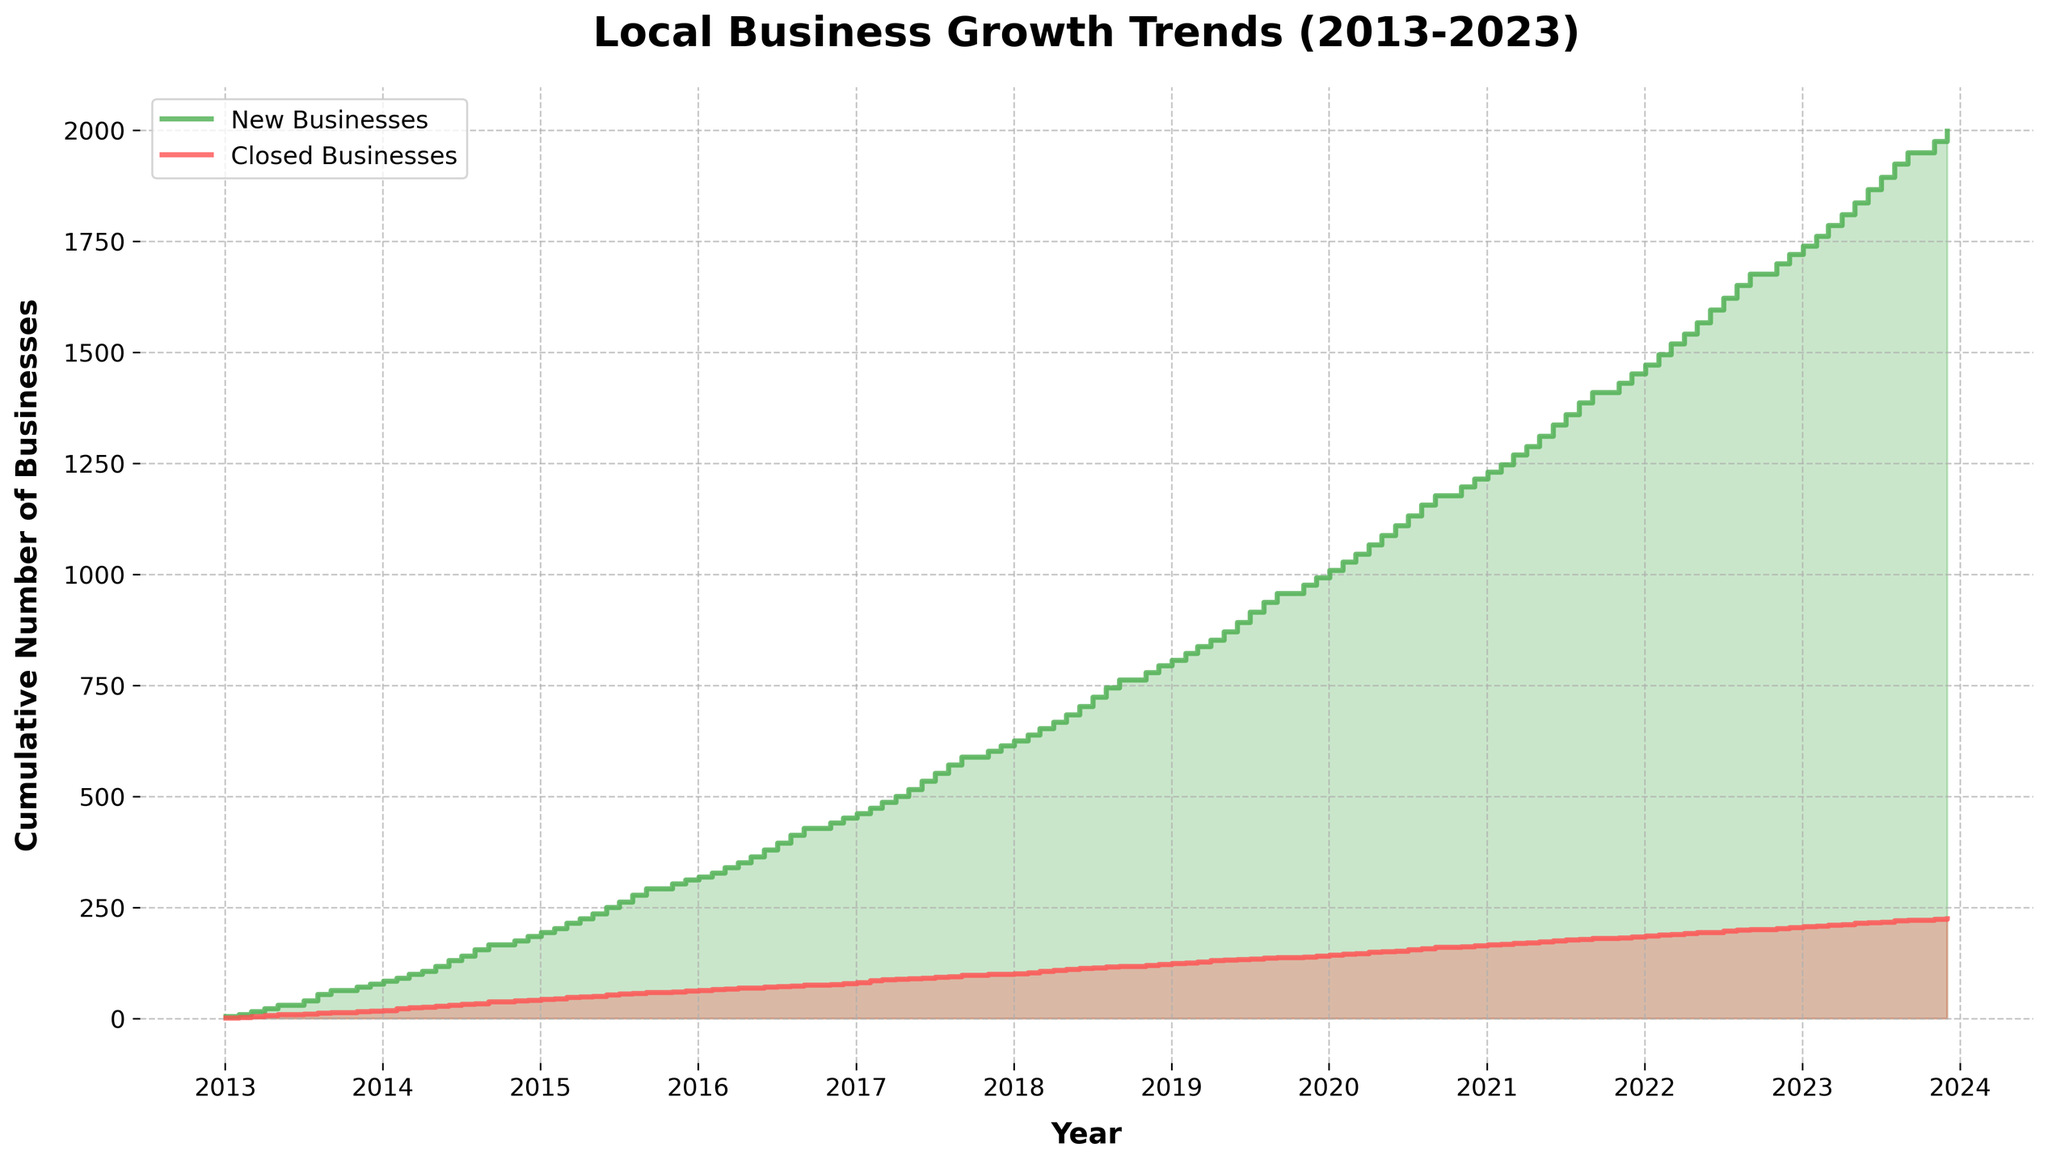What are the two lines representing in the figure? The figure has a title indicating it shows Local Business Growth Trends Over the Last Decade. The legend displays two labels: "New Businesses" and "Closed Businesses," which correlate with the two lines representing cumulative counts of new and closed businesses over time.
Answer: New businesses and closed businesses How many new businesses were opened by the end of 2023? By following the green line to its end point on the right-hand side of the plot, it reaches a cumulative count at the end of 2023. Estimating from the axis, it looks like approximately 472 new businesses were opened by the end of 2023.
Answer: 472 What is the trend observed for closed businesses between 2013 and 2023? Observing the red line throughout the plot, it continually increases from the left to the right, indicating that the number of closed businesses cumulatively increased over this period.
Answer: Increasing In which year was the highest number of new businesses opened in a single month? The plot allows comparing vertical leaps between steps for new businesses. The largest leap is around mid-2023, corresponding to July, when 30 new businesses were opened.
Answer: 2023 Which year had the smallest number of closed businesses? Observing the red line, the smallest steps occur in the year 2013, indicating fewer businesses closed in that year compared to others.
Answer: 2013 How many total businesses were closed by the end of 2016? Follow the red line to its position at the end of 2016. It reaches approximately the level corresponding to 47 from the adopted scale.
Answer: 47 What can you infer about the growth trend of local businesses by comparing the two lines in 2020? In 2020, both lines' steps show significant increases; however, the green line for new businesses shows higher steps with more consistency throughout the year, indicating rapid growth.
Answer: Rapid growth and more consistent During which month and year were the new businesses' numbers greater than the closed businesses by the largest margin? Determining the greatest vertical distance between the green and red lines represents the greatest margin. This occurs roughly around August 2023, where new businesses opened reached 30, significantly higher than closed businesses.
Answer: August 2023 Are there any instances where the cumulative number of closed businesses decreased? Observing a stair plot, a decrease would appear as a downward step which is not present in the plot, indicating no decrease in cumulative closed businesses.
Answer: No What's the cumulative difference between new and closed businesses at the end of 2021? The difference can be calculated by estimating the vertical distance between the two lines at the end of 2021: New businesses (~361) - Closed businesses (~78) = 283.
Answer: 283 